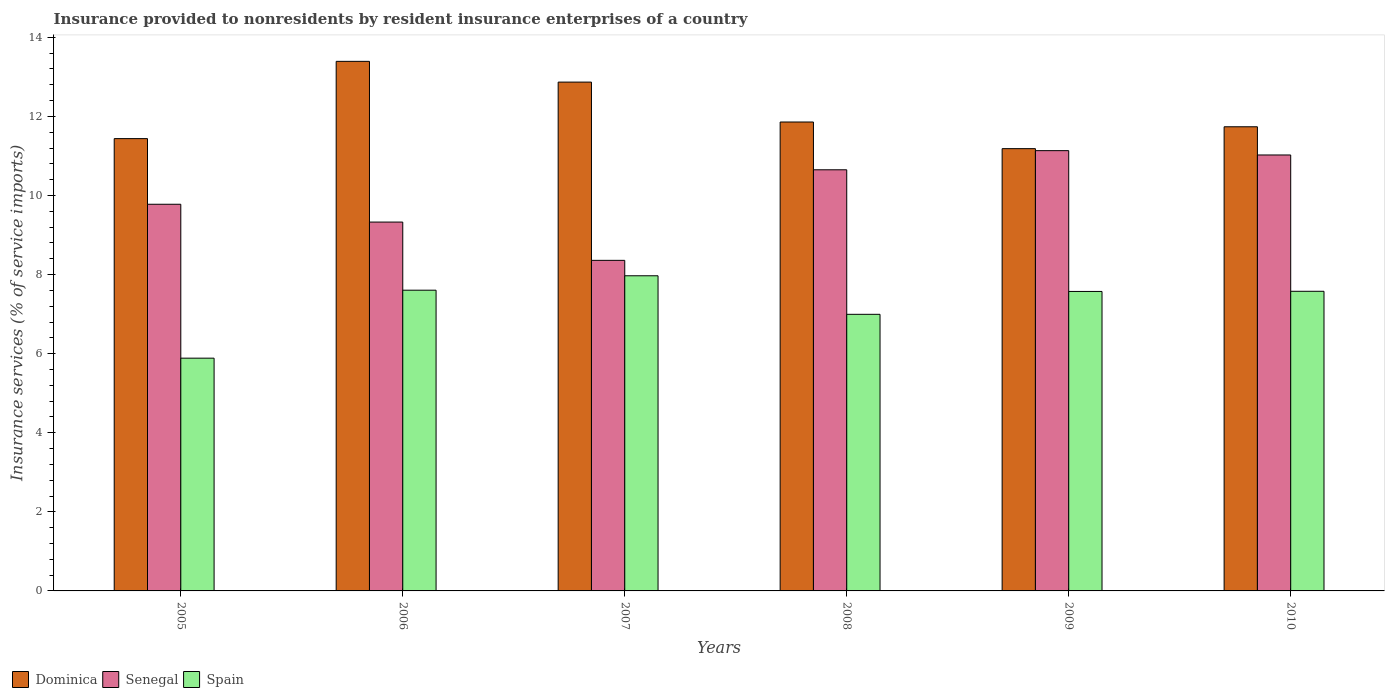How many groups of bars are there?
Your answer should be compact. 6. How many bars are there on the 5th tick from the left?
Offer a very short reply. 3. How many bars are there on the 6th tick from the right?
Make the answer very short. 3. What is the insurance provided to nonresidents in Dominica in 2008?
Provide a short and direct response. 11.86. Across all years, what is the maximum insurance provided to nonresidents in Senegal?
Keep it short and to the point. 11.13. Across all years, what is the minimum insurance provided to nonresidents in Spain?
Your response must be concise. 5.89. In which year was the insurance provided to nonresidents in Senegal maximum?
Your answer should be very brief. 2009. In which year was the insurance provided to nonresidents in Senegal minimum?
Offer a very short reply. 2007. What is the total insurance provided to nonresidents in Spain in the graph?
Keep it short and to the point. 43.61. What is the difference between the insurance provided to nonresidents in Senegal in 2006 and that in 2008?
Ensure brevity in your answer.  -1.32. What is the difference between the insurance provided to nonresidents in Senegal in 2007 and the insurance provided to nonresidents in Dominica in 2010?
Provide a short and direct response. -3.38. What is the average insurance provided to nonresidents in Spain per year?
Offer a terse response. 7.27. In the year 2009, what is the difference between the insurance provided to nonresidents in Senegal and insurance provided to nonresidents in Dominica?
Keep it short and to the point. -0.05. What is the ratio of the insurance provided to nonresidents in Senegal in 2007 to that in 2008?
Your answer should be compact. 0.78. Is the insurance provided to nonresidents in Dominica in 2005 less than that in 2007?
Give a very brief answer. Yes. What is the difference between the highest and the second highest insurance provided to nonresidents in Spain?
Your answer should be compact. 0.36. What is the difference between the highest and the lowest insurance provided to nonresidents in Dominica?
Your response must be concise. 2.21. In how many years, is the insurance provided to nonresidents in Spain greater than the average insurance provided to nonresidents in Spain taken over all years?
Make the answer very short. 4. What does the 2nd bar from the left in 2007 represents?
Ensure brevity in your answer.  Senegal. What does the 1st bar from the right in 2008 represents?
Offer a very short reply. Spain. Is it the case that in every year, the sum of the insurance provided to nonresidents in Dominica and insurance provided to nonresidents in Spain is greater than the insurance provided to nonresidents in Senegal?
Your response must be concise. Yes. How many bars are there?
Your answer should be very brief. 18. Are all the bars in the graph horizontal?
Your answer should be very brief. No. What is the difference between two consecutive major ticks on the Y-axis?
Your answer should be very brief. 2. Does the graph contain grids?
Offer a terse response. No. How many legend labels are there?
Make the answer very short. 3. How are the legend labels stacked?
Ensure brevity in your answer.  Horizontal. What is the title of the graph?
Ensure brevity in your answer.  Insurance provided to nonresidents by resident insurance enterprises of a country. Does "Colombia" appear as one of the legend labels in the graph?
Make the answer very short. No. What is the label or title of the X-axis?
Provide a short and direct response. Years. What is the label or title of the Y-axis?
Your answer should be very brief. Insurance services (% of service imports). What is the Insurance services (% of service imports) of Dominica in 2005?
Make the answer very short. 11.44. What is the Insurance services (% of service imports) of Senegal in 2005?
Ensure brevity in your answer.  9.78. What is the Insurance services (% of service imports) of Spain in 2005?
Provide a short and direct response. 5.89. What is the Insurance services (% of service imports) of Dominica in 2006?
Offer a terse response. 13.39. What is the Insurance services (% of service imports) of Senegal in 2006?
Give a very brief answer. 9.33. What is the Insurance services (% of service imports) in Spain in 2006?
Give a very brief answer. 7.61. What is the Insurance services (% of service imports) of Dominica in 2007?
Give a very brief answer. 12.87. What is the Insurance services (% of service imports) in Senegal in 2007?
Ensure brevity in your answer.  8.36. What is the Insurance services (% of service imports) of Spain in 2007?
Provide a succinct answer. 7.97. What is the Insurance services (% of service imports) of Dominica in 2008?
Provide a succinct answer. 11.86. What is the Insurance services (% of service imports) of Senegal in 2008?
Provide a short and direct response. 10.65. What is the Insurance services (% of service imports) in Spain in 2008?
Make the answer very short. 7. What is the Insurance services (% of service imports) of Dominica in 2009?
Provide a succinct answer. 11.19. What is the Insurance services (% of service imports) of Senegal in 2009?
Keep it short and to the point. 11.13. What is the Insurance services (% of service imports) in Spain in 2009?
Your answer should be compact. 7.57. What is the Insurance services (% of service imports) in Dominica in 2010?
Keep it short and to the point. 11.74. What is the Insurance services (% of service imports) in Senegal in 2010?
Your answer should be compact. 11.03. What is the Insurance services (% of service imports) in Spain in 2010?
Keep it short and to the point. 7.58. Across all years, what is the maximum Insurance services (% of service imports) in Dominica?
Ensure brevity in your answer.  13.39. Across all years, what is the maximum Insurance services (% of service imports) of Senegal?
Keep it short and to the point. 11.13. Across all years, what is the maximum Insurance services (% of service imports) in Spain?
Provide a succinct answer. 7.97. Across all years, what is the minimum Insurance services (% of service imports) in Dominica?
Give a very brief answer. 11.19. Across all years, what is the minimum Insurance services (% of service imports) in Senegal?
Your response must be concise. 8.36. Across all years, what is the minimum Insurance services (% of service imports) of Spain?
Make the answer very short. 5.89. What is the total Insurance services (% of service imports) in Dominica in the graph?
Offer a terse response. 72.48. What is the total Insurance services (% of service imports) in Senegal in the graph?
Make the answer very short. 60.28. What is the total Insurance services (% of service imports) in Spain in the graph?
Your answer should be very brief. 43.61. What is the difference between the Insurance services (% of service imports) in Dominica in 2005 and that in 2006?
Your answer should be compact. -1.95. What is the difference between the Insurance services (% of service imports) of Senegal in 2005 and that in 2006?
Your answer should be very brief. 0.45. What is the difference between the Insurance services (% of service imports) of Spain in 2005 and that in 2006?
Make the answer very short. -1.72. What is the difference between the Insurance services (% of service imports) in Dominica in 2005 and that in 2007?
Offer a very short reply. -1.43. What is the difference between the Insurance services (% of service imports) in Senegal in 2005 and that in 2007?
Provide a succinct answer. 1.42. What is the difference between the Insurance services (% of service imports) in Spain in 2005 and that in 2007?
Your answer should be compact. -2.08. What is the difference between the Insurance services (% of service imports) in Dominica in 2005 and that in 2008?
Give a very brief answer. -0.42. What is the difference between the Insurance services (% of service imports) in Senegal in 2005 and that in 2008?
Your response must be concise. -0.87. What is the difference between the Insurance services (% of service imports) in Spain in 2005 and that in 2008?
Ensure brevity in your answer.  -1.11. What is the difference between the Insurance services (% of service imports) of Dominica in 2005 and that in 2009?
Your answer should be compact. 0.25. What is the difference between the Insurance services (% of service imports) in Senegal in 2005 and that in 2009?
Offer a very short reply. -1.36. What is the difference between the Insurance services (% of service imports) in Spain in 2005 and that in 2009?
Ensure brevity in your answer.  -1.69. What is the difference between the Insurance services (% of service imports) of Dominica in 2005 and that in 2010?
Offer a terse response. -0.3. What is the difference between the Insurance services (% of service imports) in Senegal in 2005 and that in 2010?
Provide a short and direct response. -1.25. What is the difference between the Insurance services (% of service imports) of Spain in 2005 and that in 2010?
Ensure brevity in your answer.  -1.69. What is the difference between the Insurance services (% of service imports) in Dominica in 2006 and that in 2007?
Your response must be concise. 0.52. What is the difference between the Insurance services (% of service imports) of Senegal in 2006 and that in 2007?
Give a very brief answer. 0.97. What is the difference between the Insurance services (% of service imports) of Spain in 2006 and that in 2007?
Your answer should be compact. -0.36. What is the difference between the Insurance services (% of service imports) in Dominica in 2006 and that in 2008?
Your answer should be compact. 1.53. What is the difference between the Insurance services (% of service imports) in Senegal in 2006 and that in 2008?
Your response must be concise. -1.32. What is the difference between the Insurance services (% of service imports) of Spain in 2006 and that in 2008?
Your answer should be very brief. 0.61. What is the difference between the Insurance services (% of service imports) of Dominica in 2006 and that in 2009?
Keep it short and to the point. 2.21. What is the difference between the Insurance services (% of service imports) in Senegal in 2006 and that in 2009?
Keep it short and to the point. -1.81. What is the difference between the Insurance services (% of service imports) in Spain in 2006 and that in 2009?
Offer a terse response. 0.03. What is the difference between the Insurance services (% of service imports) of Dominica in 2006 and that in 2010?
Keep it short and to the point. 1.65. What is the difference between the Insurance services (% of service imports) in Senegal in 2006 and that in 2010?
Your response must be concise. -1.7. What is the difference between the Insurance services (% of service imports) of Spain in 2006 and that in 2010?
Your response must be concise. 0.03. What is the difference between the Insurance services (% of service imports) of Dominica in 2007 and that in 2008?
Offer a very short reply. 1.01. What is the difference between the Insurance services (% of service imports) of Senegal in 2007 and that in 2008?
Your answer should be compact. -2.29. What is the difference between the Insurance services (% of service imports) of Spain in 2007 and that in 2008?
Make the answer very short. 0.97. What is the difference between the Insurance services (% of service imports) of Dominica in 2007 and that in 2009?
Provide a short and direct response. 1.68. What is the difference between the Insurance services (% of service imports) in Senegal in 2007 and that in 2009?
Make the answer very short. -2.77. What is the difference between the Insurance services (% of service imports) of Spain in 2007 and that in 2009?
Provide a succinct answer. 0.4. What is the difference between the Insurance services (% of service imports) of Dominica in 2007 and that in 2010?
Ensure brevity in your answer.  1.13. What is the difference between the Insurance services (% of service imports) in Senegal in 2007 and that in 2010?
Make the answer very short. -2.67. What is the difference between the Insurance services (% of service imports) of Spain in 2007 and that in 2010?
Your response must be concise. 0.39. What is the difference between the Insurance services (% of service imports) in Dominica in 2008 and that in 2009?
Offer a terse response. 0.67. What is the difference between the Insurance services (% of service imports) in Senegal in 2008 and that in 2009?
Your response must be concise. -0.48. What is the difference between the Insurance services (% of service imports) of Spain in 2008 and that in 2009?
Your response must be concise. -0.58. What is the difference between the Insurance services (% of service imports) of Dominica in 2008 and that in 2010?
Keep it short and to the point. 0.12. What is the difference between the Insurance services (% of service imports) of Senegal in 2008 and that in 2010?
Your answer should be compact. -0.37. What is the difference between the Insurance services (% of service imports) in Spain in 2008 and that in 2010?
Provide a succinct answer. -0.58. What is the difference between the Insurance services (% of service imports) of Dominica in 2009 and that in 2010?
Offer a terse response. -0.55. What is the difference between the Insurance services (% of service imports) of Senegal in 2009 and that in 2010?
Offer a very short reply. 0.11. What is the difference between the Insurance services (% of service imports) of Spain in 2009 and that in 2010?
Offer a terse response. -0. What is the difference between the Insurance services (% of service imports) of Dominica in 2005 and the Insurance services (% of service imports) of Senegal in 2006?
Ensure brevity in your answer.  2.11. What is the difference between the Insurance services (% of service imports) of Dominica in 2005 and the Insurance services (% of service imports) of Spain in 2006?
Ensure brevity in your answer.  3.83. What is the difference between the Insurance services (% of service imports) in Senegal in 2005 and the Insurance services (% of service imports) in Spain in 2006?
Make the answer very short. 2.17. What is the difference between the Insurance services (% of service imports) in Dominica in 2005 and the Insurance services (% of service imports) in Senegal in 2007?
Your answer should be very brief. 3.08. What is the difference between the Insurance services (% of service imports) of Dominica in 2005 and the Insurance services (% of service imports) of Spain in 2007?
Provide a short and direct response. 3.47. What is the difference between the Insurance services (% of service imports) in Senegal in 2005 and the Insurance services (% of service imports) in Spain in 2007?
Your answer should be compact. 1.81. What is the difference between the Insurance services (% of service imports) of Dominica in 2005 and the Insurance services (% of service imports) of Senegal in 2008?
Your response must be concise. 0.79. What is the difference between the Insurance services (% of service imports) of Dominica in 2005 and the Insurance services (% of service imports) of Spain in 2008?
Provide a short and direct response. 4.44. What is the difference between the Insurance services (% of service imports) in Senegal in 2005 and the Insurance services (% of service imports) in Spain in 2008?
Your answer should be very brief. 2.78. What is the difference between the Insurance services (% of service imports) of Dominica in 2005 and the Insurance services (% of service imports) of Senegal in 2009?
Keep it short and to the point. 0.3. What is the difference between the Insurance services (% of service imports) of Dominica in 2005 and the Insurance services (% of service imports) of Spain in 2009?
Give a very brief answer. 3.87. What is the difference between the Insurance services (% of service imports) of Senegal in 2005 and the Insurance services (% of service imports) of Spain in 2009?
Make the answer very short. 2.21. What is the difference between the Insurance services (% of service imports) in Dominica in 2005 and the Insurance services (% of service imports) in Senegal in 2010?
Give a very brief answer. 0.41. What is the difference between the Insurance services (% of service imports) in Dominica in 2005 and the Insurance services (% of service imports) in Spain in 2010?
Make the answer very short. 3.86. What is the difference between the Insurance services (% of service imports) of Senegal in 2005 and the Insurance services (% of service imports) of Spain in 2010?
Give a very brief answer. 2.2. What is the difference between the Insurance services (% of service imports) in Dominica in 2006 and the Insurance services (% of service imports) in Senegal in 2007?
Provide a short and direct response. 5.03. What is the difference between the Insurance services (% of service imports) of Dominica in 2006 and the Insurance services (% of service imports) of Spain in 2007?
Ensure brevity in your answer.  5.42. What is the difference between the Insurance services (% of service imports) in Senegal in 2006 and the Insurance services (% of service imports) in Spain in 2007?
Ensure brevity in your answer.  1.36. What is the difference between the Insurance services (% of service imports) in Dominica in 2006 and the Insurance services (% of service imports) in Senegal in 2008?
Keep it short and to the point. 2.74. What is the difference between the Insurance services (% of service imports) in Dominica in 2006 and the Insurance services (% of service imports) in Spain in 2008?
Your response must be concise. 6.4. What is the difference between the Insurance services (% of service imports) of Senegal in 2006 and the Insurance services (% of service imports) of Spain in 2008?
Make the answer very short. 2.33. What is the difference between the Insurance services (% of service imports) in Dominica in 2006 and the Insurance services (% of service imports) in Senegal in 2009?
Give a very brief answer. 2.26. What is the difference between the Insurance services (% of service imports) of Dominica in 2006 and the Insurance services (% of service imports) of Spain in 2009?
Your answer should be compact. 5.82. What is the difference between the Insurance services (% of service imports) of Senegal in 2006 and the Insurance services (% of service imports) of Spain in 2009?
Your response must be concise. 1.75. What is the difference between the Insurance services (% of service imports) of Dominica in 2006 and the Insurance services (% of service imports) of Senegal in 2010?
Ensure brevity in your answer.  2.37. What is the difference between the Insurance services (% of service imports) in Dominica in 2006 and the Insurance services (% of service imports) in Spain in 2010?
Offer a terse response. 5.82. What is the difference between the Insurance services (% of service imports) in Senegal in 2006 and the Insurance services (% of service imports) in Spain in 2010?
Keep it short and to the point. 1.75. What is the difference between the Insurance services (% of service imports) of Dominica in 2007 and the Insurance services (% of service imports) of Senegal in 2008?
Provide a short and direct response. 2.22. What is the difference between the Insurance services (% of service imports) of Dominica in 2007 and the Insurance services (% of service imports) of Spain in 2008?
Your answer should be compact. 5.87. What is the difference between the Insurance services (% of service imports) of Senegal in 2007 and the Insurance services (% of service imports) of Spain in 2008?
Ensure brevity in your answer.  1.36. What is the difference between the Insurance services (% of service imports) in Dominica in 2007 and the Insurance services (% of service imports) in Senegal in 2009?
Make the answer very short. 1.73. What is the difference between the Insurance services (% of service imports) in Dominica in 2007 and the Insurance services (% of service imports) in Spain in 2009?
Provide a succinct answer. 5.29. What is the difference between the Insurance services (% of service imports) of Senegal in 2007 and the Insurance services (% of service imports) of Spain in 2009?
Your response must be concise. 0.79. What is the difference between the Insurance services (% of service imports) in Dominica in 2007 and the Insurance services (% of service imports) in Senegal in 2010?
Ensure brevity in your answer.  1.84. What is the difference between the Insurance services (% of service imports) of Dominica in 2007 and the Insurance services (% of service imports) of Spain in 2010?
Your response must be concise. 5.29. What is the difference between the Insurance services (% of service imports) in Senegal in 2007 and the Insurance services (% of service imports) in Spain in 2010?
Offer a terse response. 0.78. What is the difference between the Insurance services (% of service imports) of Dominica in 2008 and the Insurance services (% of service imports) of Senegal in 2009?
Ensure brevity in your answer.  0.72. What is the difference between the Insurance services (% of service imports) of Dominica in 2008 and the Insurance services (% of service imports) of Spain in 2009?
Your answer should be very brief. 4.29. What is the difference between the Insurance services (% of service imports) of Senegal in 2008 and the Insurance services (% of service imports) of Spain in 2009?
Offer a terse response. 3.08. What is the difference between the Insurance services (% of service imports) of Dominica in 2008 and the Insurance services (% of service imports) of Senegal in 2010?
Your response must be concise. 0.83. What is the difference between the Insurance services (% of service imports) in Dominica in 2008 and the Insurance services (% of service imports) in Spain in 2010?
Provide a succinct answer. 4.28. What is the difference between the Insurance services (% of service imports) of Senegal in 2008 and the Insurance services (% of service imports) of Spain in 2010?
Your answer should be compact. 3.07. What is the difference between the Insurance services (% of service imports) of Dominica in 2009 and the Insurance services (% of service imports) of Senegal in 2010?
Make the answer very short. 0.16. What is the difference between the Insurance services (% of service imports) in Dominica in 2009 and the Insurance services (% of service imports) in Spain in 2010?
Offer a very short reply. 3.61. What is the difference between the Insurance services (% of service imports) of Senegal in 2009 and the Insurance services (% of service imports) of Spain in 2010?
Keep it short and to the point. 3.56. What is the average Insurance services (% of service imports) in Dominica per year?
Offer a very short reply. 12.08. What is the average Insurance services (% of service imports) of Senegal per year?
Your answer should be compact. 10.05. What is the average Insurance services (% of service imports) in Spain per year?
Provide a short and direct response. 7.27. In the year 2005, what is the difference between the Insurance services (% of service imports) in Dominica and Insurance services (% of service imports) in Senegal?
Make the answer very short. 1.66. In the year 2005, what is the difference between the Insurance services (% of service imports) in Dominica and Insurance services (% of service imports) in Spain?
Offer a very short reply. 5.55. In the year 2005, what is the difference between the Insurance services (% of service imports) of Senegal and Insurance services (% of service imports) of Spain?
Ensure brevity in your answer.  3.89. In the year 2006, what is the difference between the Insurance services (% of service imports) of Dominica and Insurance services (% of service imports) of Senegal?
Your answer should be very brief. 4.06. In the year 2006, what is the difference between the Insurance services (% of service imports) in Dominica and Insurance services (% of service imports) in Spain?
Your answer should be very brief. 5.79. In the year 2006, what is the difference between the Insurance services (% of service imports) of Senegal and Insurance services (% of service imports) of Spain?
Make the answer very short. 1.72. In the year 2007, what is the difference between the Insurance services (% of service imports) of Dominica and Insurance services (% of service imports) of Senegal?
Give a very brief answer. 4.51. In the year 2007, what is the difference between the Insurance services (% of service imports) of Dominica and Insurance services (% of service imports) of Spain?
Your answer should be compact. 4.9. In the year 2007, what is the difference between the Insurance services (% of service imports) in Senegal and Insurance services (% of service imports) in Spain?
Give a very brief answer. 0.39. In the year 2008, what is the difference between the Insurance services (% of service imports) in Dominica and Insurance services (% of service imports) in Senegal?
Your answer should be compact. 1.21. In the year 2008, what is the difference between the Insurance services (% of service imports) in Dominica and Insurance services (% of service imports) in Spain?
Give a very brief answer. 4.86. In the year 2008, what is the difference between the Insurance services (% of service imports) of Senegal and Insurance services (% of service imports) of Spain?
Your answer should be compact. 3.66. In the year 2009, what is the difference between the Insurance services (% of service imports) in Dominica and Insurance services (% of service imports) in Senegal?
Offer a very short reply. 0.05. In the year 2009, what is the difference between the Insurance services (% of service imports) in Dominica and Insurance services (% of service imports) in Spain?
Ensure brevity in your answer.  3.61. In the year 2009, what is the difference between the Insurance services (% of service imports) of Senegal and Insurance services (% of service imports) of Spain?
Offer a very short reply. 3.56. In the year 2010, what is the difference between the Insurance services (% of service imports) in Dominica and Insurance services (% of service imports) in Senegal?
Provide a short and direct response. 0.71. In the year 2010, what is the difference between the Insurance services (% of service imports) of Dominica and Insurance services (% of service imports) of Spain?
Provide a succinct answer. 4.16. In the year 2010, what is the difference between the Insurance services (% of service imports) in Senegal and Insurance services (% of service imports) in Spain?
Your response must be concise. 3.45. What is the ratio of the Insurance services (% of service imports) of Dominica in 2005 to that in 2006?
Your answer should be very brief. 0.85. What is the ratio of the Insurance services (% of service imports) in Senegal in 2005 to that in 2006?
Offer a terse response. 1.05. What is the ratio of the Insurance services (% of service imports) in Spain in 2005 to that in 2006?
Give a very brief answer. 0.77. What is the ratio of the Insurance services (% of service imports) of Senegal in 2005 to that in 2007?
Offer a terse response. 1.17. What is the ratio of the Insurance services (% of service imports) in Spain in 2005 to that in 2007?
Give a very brief answer. 0.74. What is the ratio of the Insurance services (% of service imports) of Dominica in 2005 to that in 2008?
Provide a short and direct response. 0.96. What is the ratio of the Insurance services (% of service imports) of Senegal in 2005 to that in 2008?
Keep it short and to the point. 0.92. What is the ratio of the Insurance services (% of service imports) in Spain in 2005 to that in 2008?
Provide a succinct answer. 0.84. What is the ratio of the Insurance services (% of service imports) of Dominica in 2005 to that in 2009?
Your answer should be compact. 1.02. What is the ratio of the Insurance services (% of service imports) of Senegal in 2005 to that in 2009?
Provide a succinct answer. 0.88. What is the ratio of the Insurance services (% of service imports) of Spain in 2005 to that in 2009?
Your answer should be very brief. 0.78. What is the ratio of the Insurance services (% of service imports) of Dominica in 2005 to that in 2010?
Offer a very short reply. 0.97. What is the ratio of the Insurance services (% of service imports) in Senegal in 2005 to that in 2010?
Make the answer very short. 0.89. What is the ratio of the Insurance services (% of service imports) of Spain in 2005 to that in 2010?
Your answer should be very brief. 0.78. What is the ratio of the Insurance services (% of service imports) in Dominica in 2006 to that in 2007?
Your response must be concise. 1.04. What is the ratio of the Insurance services (% of service imports) of Senegal in 2006 to that in 2007?
Keep it short and to the point. 1.12. What is the ratio of the Insurance services (% of service imports) of Spain in 2006 to that in 2007?
Offer a very short reply. 0.95. What is the ratio of the Insurance services (% of service imports) of Dominica in 2006 to that in 2008?
Ensure brevity in your answer.  1.13. What is the ratio of the Insurance services (% of service imports) of Senegal in 2006 to that in 2008?
Ensure brevity in your answer.  0.88. What is the ratio of the Insurance services (% of service imports) of Spain in 2006 to that in 2008?
Give a very brief answer. 1.09. What is the ratio of the Insurance services (% of service imports) in Dominica in 2006 to that in 2009?
Your answer should be very brief. 1.2. What is the ratio of the Insurance services (% of service imports) in Senegal in 2006 to that in 2009?
Your answer should be compact. 0.84. What is the ratio of the Insurance services (% of service imports) in Dominica in 2006 to that in 2010?
Your answer should be very brief. 1.14. What is the ratio of the Insurance services (% of service imports) in Senegal in 2006 to that in 2010?
Your answer should be compact. 0.85. What is the ratio of the Insurance services (% of service imports) in Dominica in 2007 to that in 2008?
Provide a succinct answer. 1.09. What is the ratio of the Insurance services (% of service imports) of Senegal in 2007 to that in 2008?
Make the answer very short. 0.78. What is the ratio of the Insurance services (% of service imports) of Spain in 2007 to that in 2008?
Provide a short and direct response. 1.14. What is the ratio of the Insurance services (% of service imports) in Dominica in 2007 to that in 2009?
Provide a succinct answer. 1.15. What is the ratio of the Insurance services (% of service imports) in Senegal in 2007 to that in 2009?
Your answer should be compact. 0.75. What is the ratio of the Insurance services (% of service imports) in Spain in 2007 to that in 2009?
Your response must be concise. 1.05. What is the ratio of the Insurance services (% of service imports) in Dominica in 2007 to that in 2010?
Provide a short and direct response. 1.1. What is the ratio of the Insurance services (% of service imports) of Senegal in 2007 to that in 2010?
Provide a short and direct response. 0.76. What is the ratio of the Insurance services (% of service imports) of Spain in 2007 to that in 2010?
Keep it short and to the point. 1.05. What is the ratio of the Insurance services (% of service imports) of Dominica in 2008 to that in 2009?
Your answer should be very brief. 1.06. What is the ratio of the Insurance services (% of service imports) of Senegal in 2008 to that in 2009?
Ensure brevity in your answer.  0.96. What is the ratio of the Insurance services (% of service imports) in Spain in 2008 to that in 2009?
Provide a short and direct response. 0.92. What is the ratio of the Insurance services (% of service imports) of Dominica in 2008 to that in 2010?
Ensure brevity in your answer.  1.01. What is the ratio of the Insurance services (% of service imports) in Spain in 2008 to that in 2010?
Make the answer very short. 0.92. What is the ratio of the Insurance services (% of service imports) of Dominica in 2009 to that in 2010?
Offer a terse response. 0.95. What is the ratio of the Insurance services (% of service imports) in Senegal in 2009 to that in 2010?
Your response must be concise. 1.01. What is the ratio of the Insurance services (% of service imports) in Spain in 2009 to that in 2010?
Make the answer very short. 1. What is the difference between the highest and the second highest Insurance services (% of service imports) of Dominica?
Give a very brief answer. 0.52. What is the difference between the highest and the second highest Insurance services (% of service imports) of Senegal?
Provide a succinct answer. 0.11. What is the difference between the highest and the second highest Insurance services (% of service imports) of Spain?
Your answer should be compact. 0.36. What is the difference between the highest and the lowest Insurance services (% of service imports) of Dominica?
Your answer should be compact. 2.21. What is the difference between the highest and the lowest Insurance services (% of service imports) of Senegal?
Your answer should be very brief. 2.77. What is the difference between the highest and the lowest Insurance services (% of service imports) in Spain?
Provide a succinct answer. 2.08. 